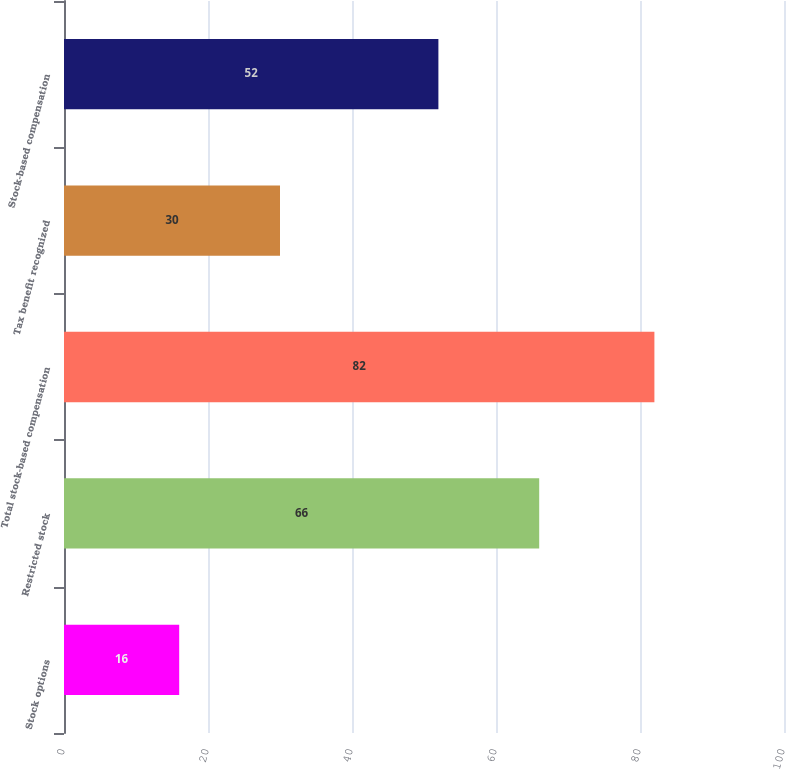Convert chart to OTSL. <chart><loc_0><loc_0><loc_500><loc_500><bar_chart><fcel>Stock options<fcel>Restricted stock<fcel>Total stock-based compensation<fcel>Tax benefit recognized<fcel>Stock-based compensation<nl><fcel>16<fcel>66<fcel>82<fcel>30<fcel>52<nl></chart> 